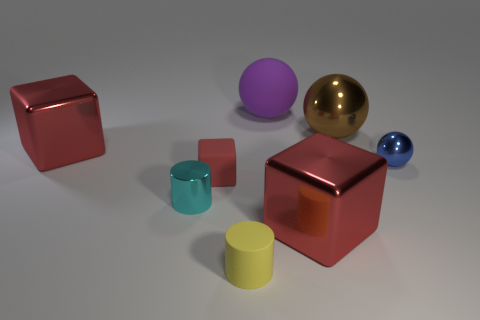How many red cubes must be subtracted to get 1 red cubes? 2 Add 2 big purple objects. How many objects exist? 10 Subtract all balls. How many objects are left? 5 Add 8 big yellow rubber balls. How many big yellow rubber balls exist? 8 Subtract 0 green blocks. How many objects are left? 8 Subtract all small red objects. Subtract all red metallic things. How many objects are left? 5 Add 6 yellow matte things. How many yellow matte things are left? 7 